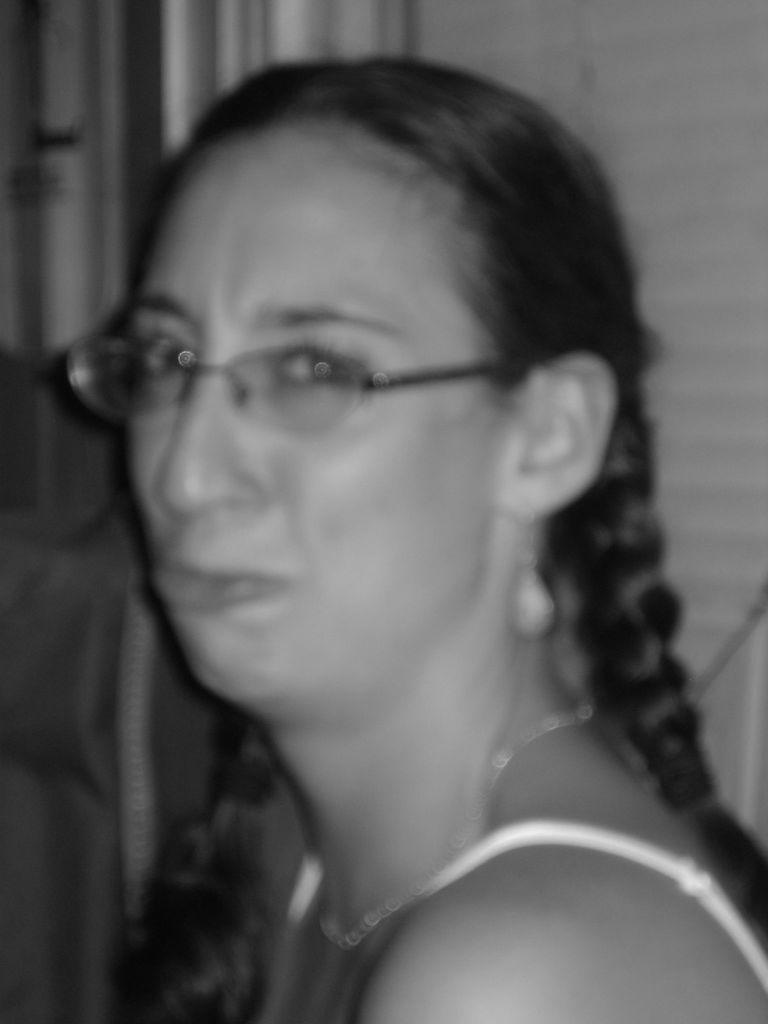Please provide a concise description of this image. This is the black and white picture of a woman. 